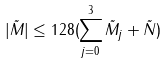<formula> <loc_0><loc_0><loc_500><loc_500>| \tilde { M } | \leq 1 2 8 ( \sum _ { j = 0 } ^ { 3 } \tilde { M } _ { j } + \tilde { N } )</formula> 